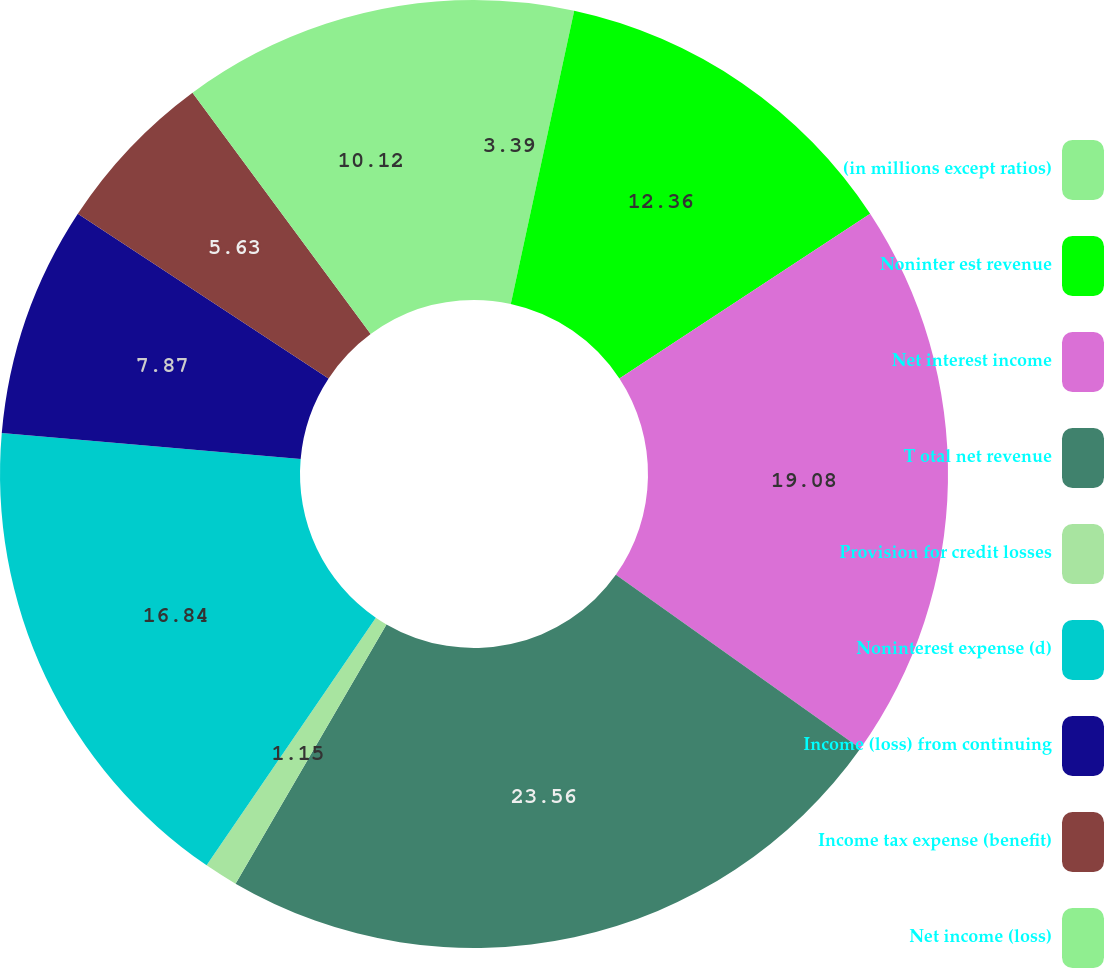Convert chart. <chart><loc_0><loc_0><loc_500><loc_500><pie_chart><fcel>(in millions except ratios)<fcel>Noninter est revenue<fcel>Net interest income<fcel>T otal net revenue<fcel>Provision for credit losses<fcel>Noninterest expense (d)<fcel>Income (loss) from continuing<fcel>Income tax expense (benefit)<fcel>Net income (loss)<nl><fcel>3.39%<fcel>12.36%<fcel>19.08%<fcel>23.56%<fcel>1.15%<fcel>16.84%<fcel>7.87%<fcel>5.63%<fcel>10.12%<nl></chart> 